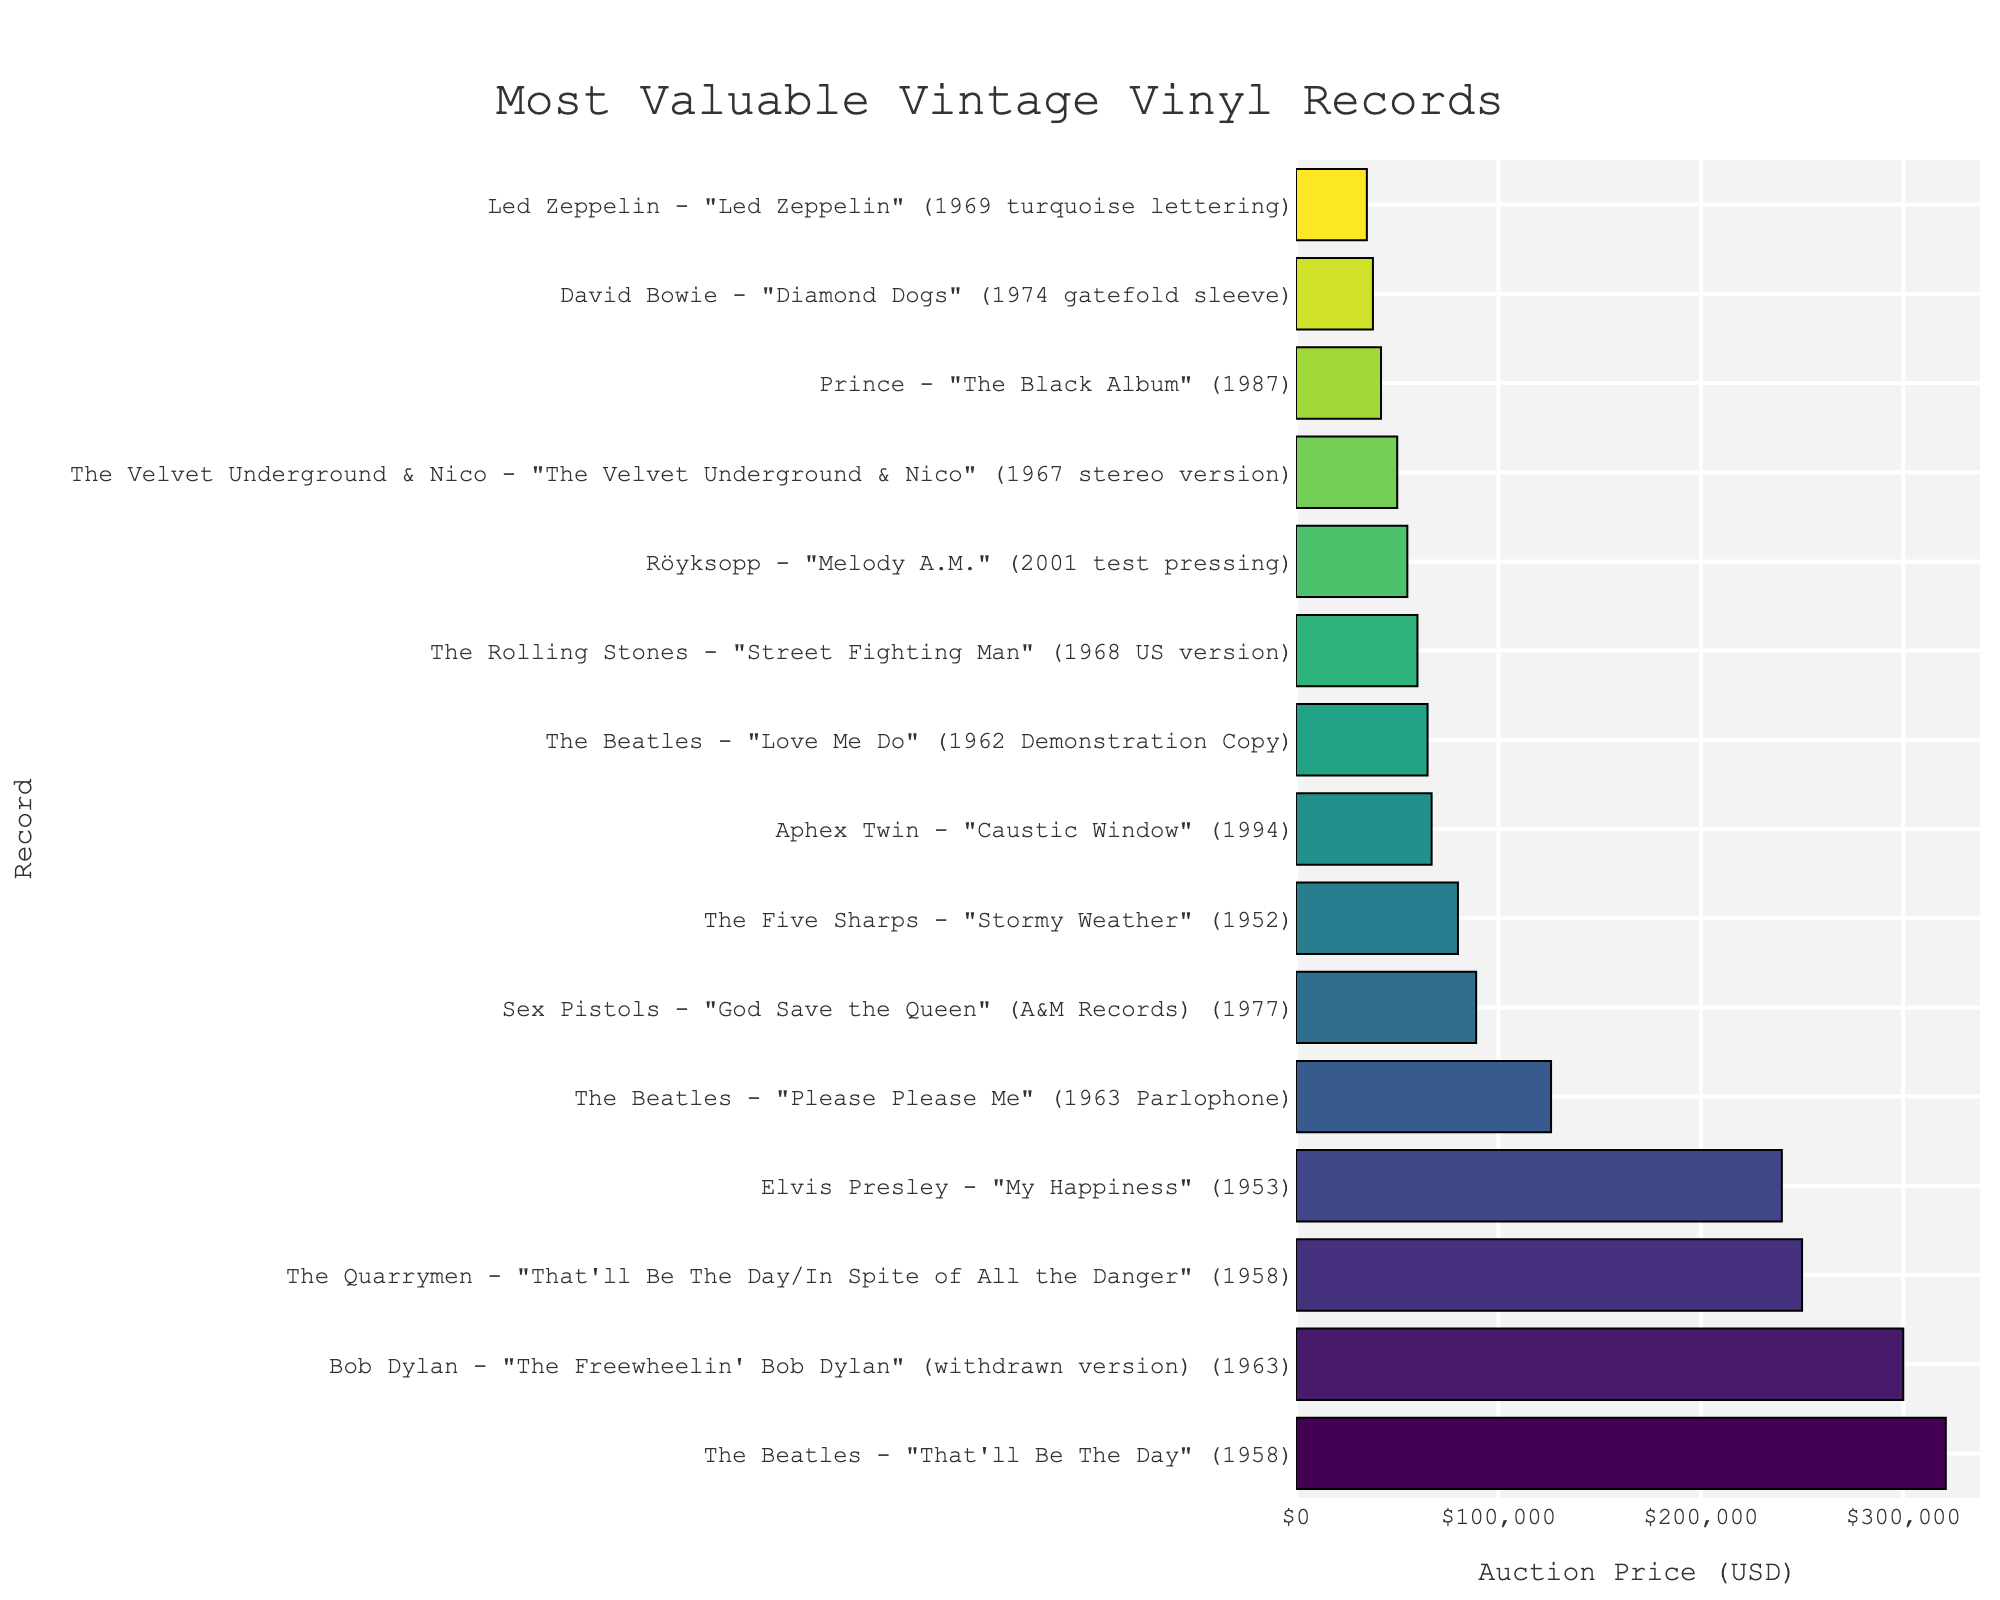What is the difference in auction price between 'The Beatles - "That'll Be The Day"' and 'The Quarrymen - "That'll Be The Day/In Spite of All the Danger"'? The auction price of 'The Beatles - "That'll Be The Day"' is $321,000, and the auction price of 'The Quarrymen - "That'll Be The Day/In Spite of All the Danger"' is $250,000. The difference is calculated as $321,000 - $250,000 = $71,000.
Answer: $71,000 Which record has a higher auction price: 'Sex Pistols - "God Save the Queen"' or 'Röyksopp - "Melody A.M."'? The auction price of 'Sex Pistols - "God Save the Queen"' is $89,000, and the auction price of 'Röyksopp - "Melody A.M."' is $55,000. Therefore, 'Sex Pistols - "God Save the Queen"' has a higher auction price.
Answer: 'Sex Pistols - "God Save the Queen"' What is the combined auction price of 'The Beatles - "Please Please Me"' and 'The Rolling Stones - "Street Fighting Man"'? The auction price of 'The Beatles - "Please Please Me"' is $126,000, and the auction price of 'The Rolling Stones - "Street Fighting Man"' is $60,000. The combined auction price is calculated as $126,000 + $60,000 = $186,000.
Answer: $186,000 Which record has the lowest auction price? The record with the lowest auction price is 'Led Zeppelin - "Led Zeppelin" (1969 turquoise lettering)', with a price of $35,000.
Answer: 'Led Zeppelin - "Led Zeppelin" (1969 turquoise lettering)' How many records have an auction price exceeding $100,000? The records with auction prices exceeding $100,000 are 'The Beatles - "That'll Be The Day"', 'Bob Dylan - "The Freewheelin' Bob Dylan"', 'The Quarrymen - "That'll Be The Day/In Spite of All the Danger"', 'Elvis Presley - "My Happiness"', and 'The Beatles - "Please Please Me"'. There are 5 such records.
Answer: 5 What is the median auction price of all listed records? To find the median price, arrange all prices in ascending order: $35,000, $38,000, $42,000, $50,000, $55,000, $60,000, $65,000, $67,000, $80,000, $89,000, $126,000, $240,000, $250,000, $300,000, and $321,000. The median price, being the middle value in this ordered list, is $67,000.
Answer: $67,000 Which records are more expensive than $200,000? The records that have auction prices exceeding $200,000 are 'The Beatles - "That'll Be The Day"', 'Bob Dylan - "The Freewheelin' Bob Dylan"', 'The Quarrymen - "That'll Be The Day/In Spite of All the Danger"', and 'Elvis Presley - "My Happiness"'.
Answer: 'The Beatles - "That'll Be The Day"', 'Bob Dylan - "The Freewheelin' Bob Dylan"', 'The Quarrymen - "That'll Be The Day/In Spite of All the Danger"', 'Elvis Presley - "My Happiness"' What is the total auction price of all records in the dataset? The total auction price is calculated by summing up all the values: 321,000 + 300,000 + 250,000 + 240,000 + 126,000 + 89,000 + 80,000 + 67,000 + 65,000 + 60,000 + 55,000 + 50,000 + 42,000 + 38,000 + 35,000 = $1,818,000.
Answer: $1,818,000 